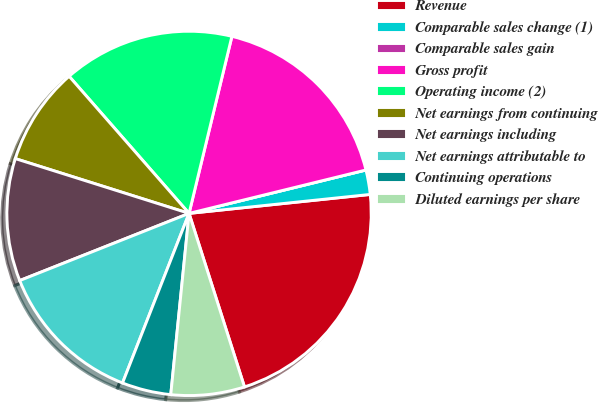Convert chart to OTSL. <chart><loc_0><loc_0><loc_500><loc_500><pie_chart><fcel>Revenue<fcel>Comparable sales change (1)<fcel>Comparable sales gain<fcel>Gross profit<fcel>Operating income (2)<fcel>Net earnings from continuing<fcel>Net earnings including<fcel>Net earnings attributable to<fcel>Continuing operations<fcel>Diluted earnings per share<nl><fcel>21.74%<fcel>2.17%<fcel>0.0%<fcel>17.39%<fcel>15.22%<fcel>8.7%<fcel>10.87%<fcel>13.04%<fcel>4.35%<fcel>6.52%<nl></chart> 